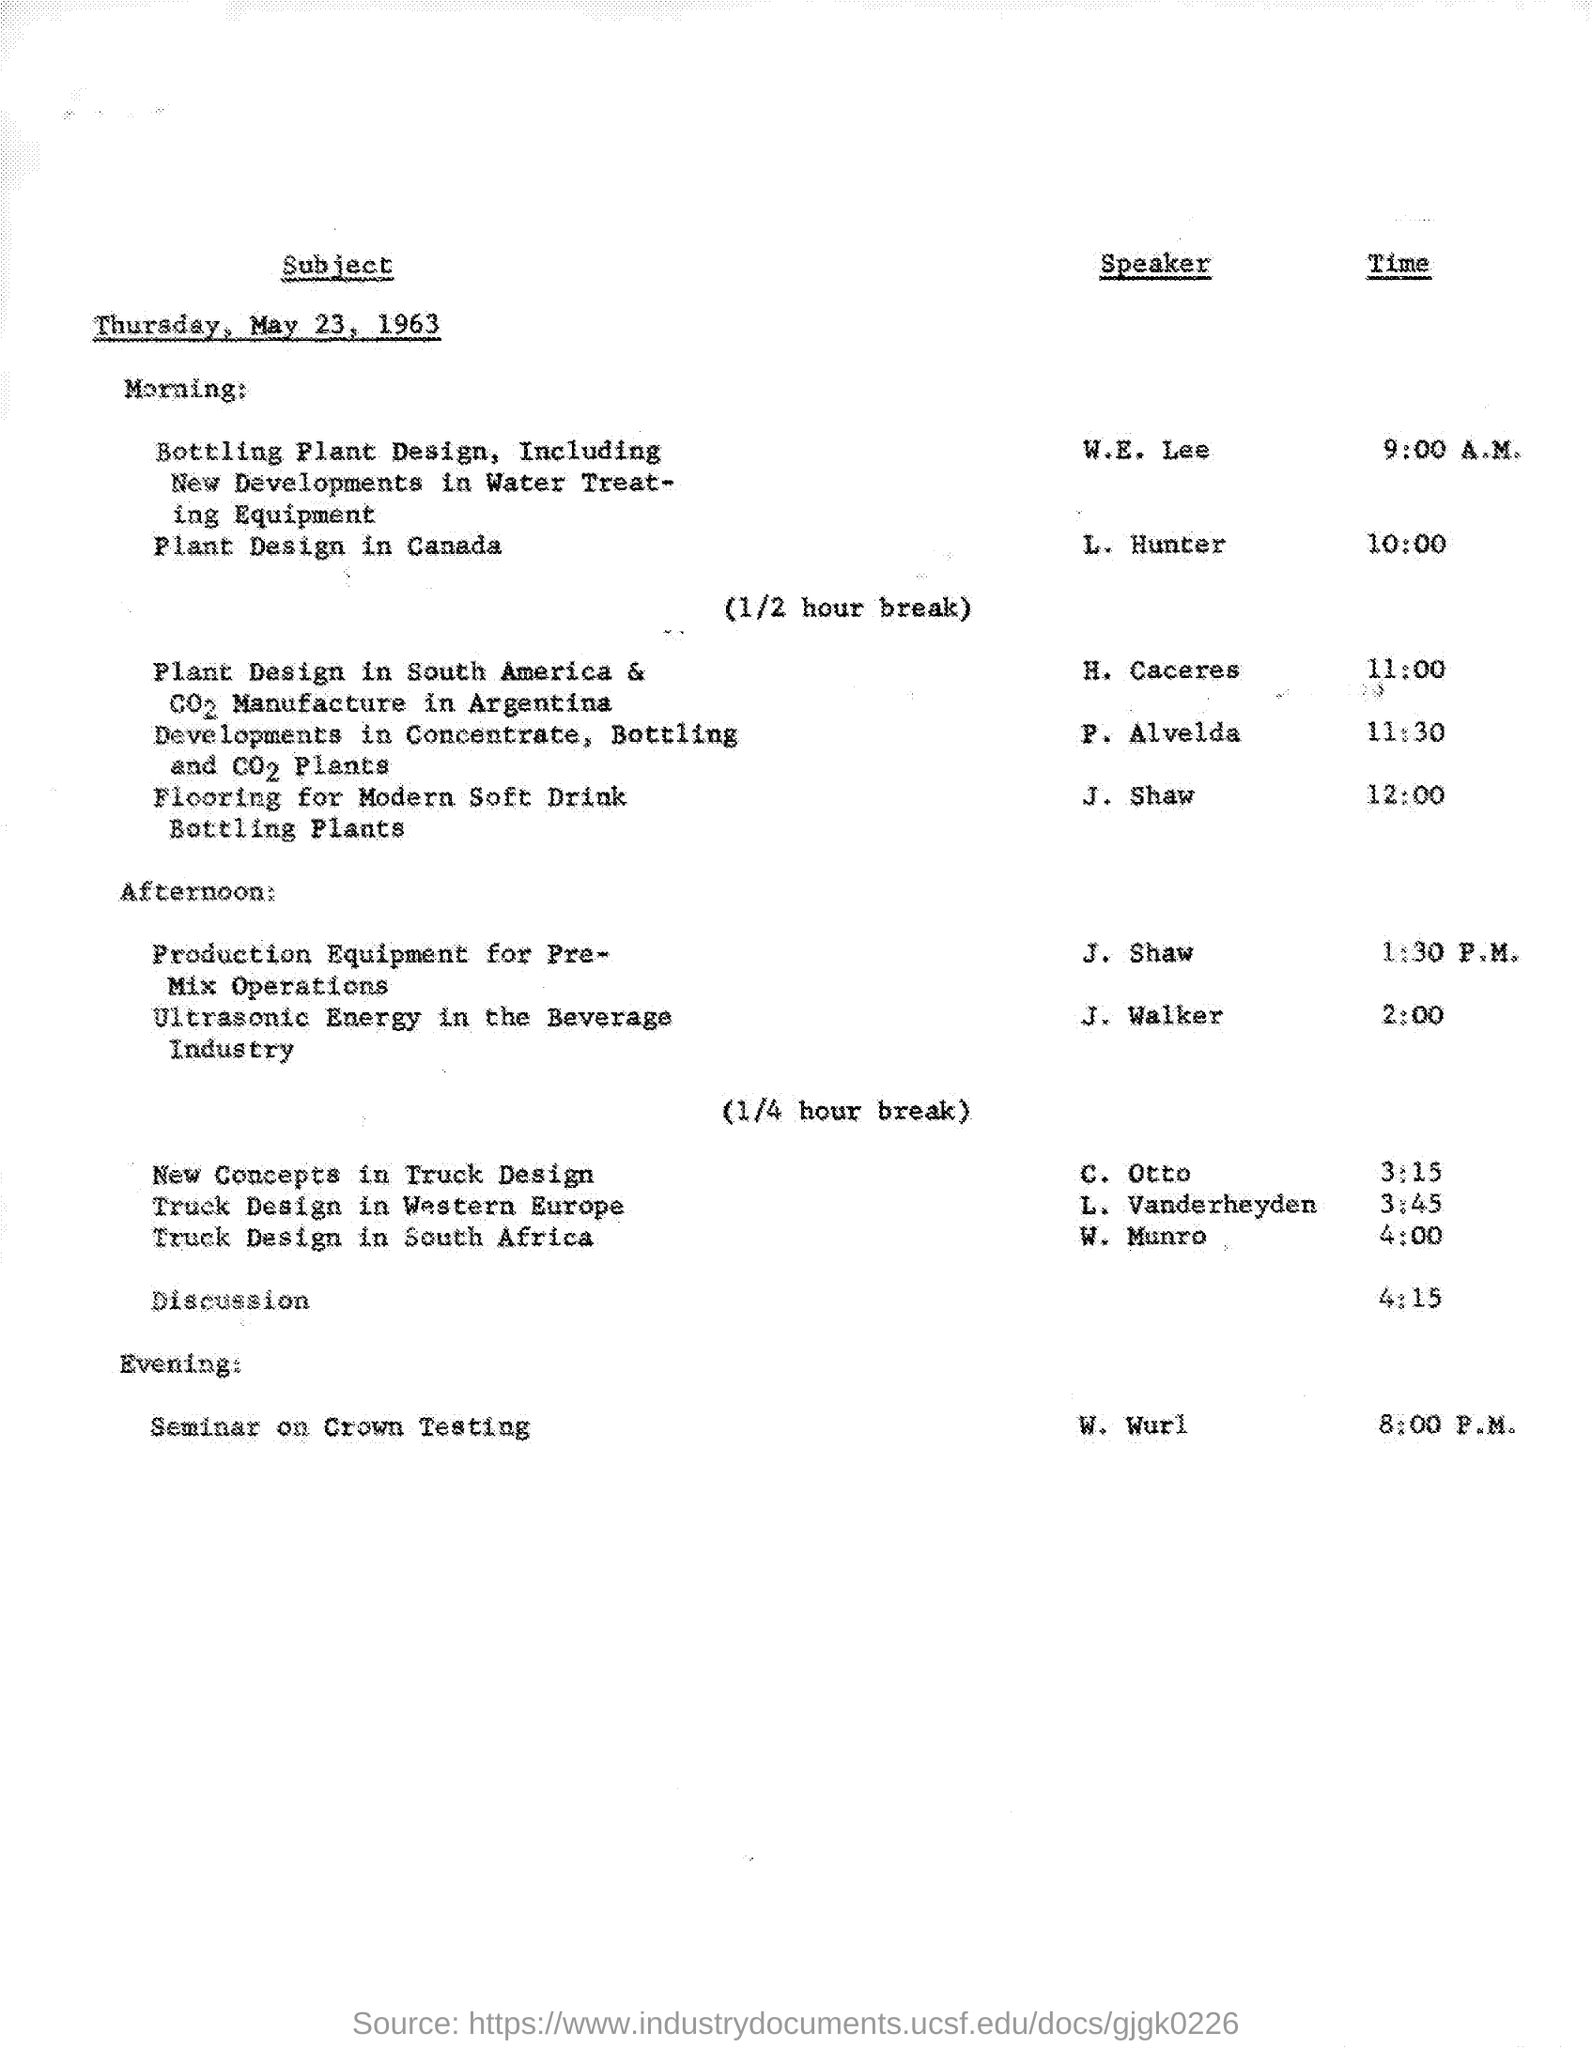Indicate a few pertinent items in this graphic. The seminar on crown testing will begin at 8:00 p.m. The speaker of the sentence "Who speaks 'Plant design in Canada'?" is L. Hunter. 